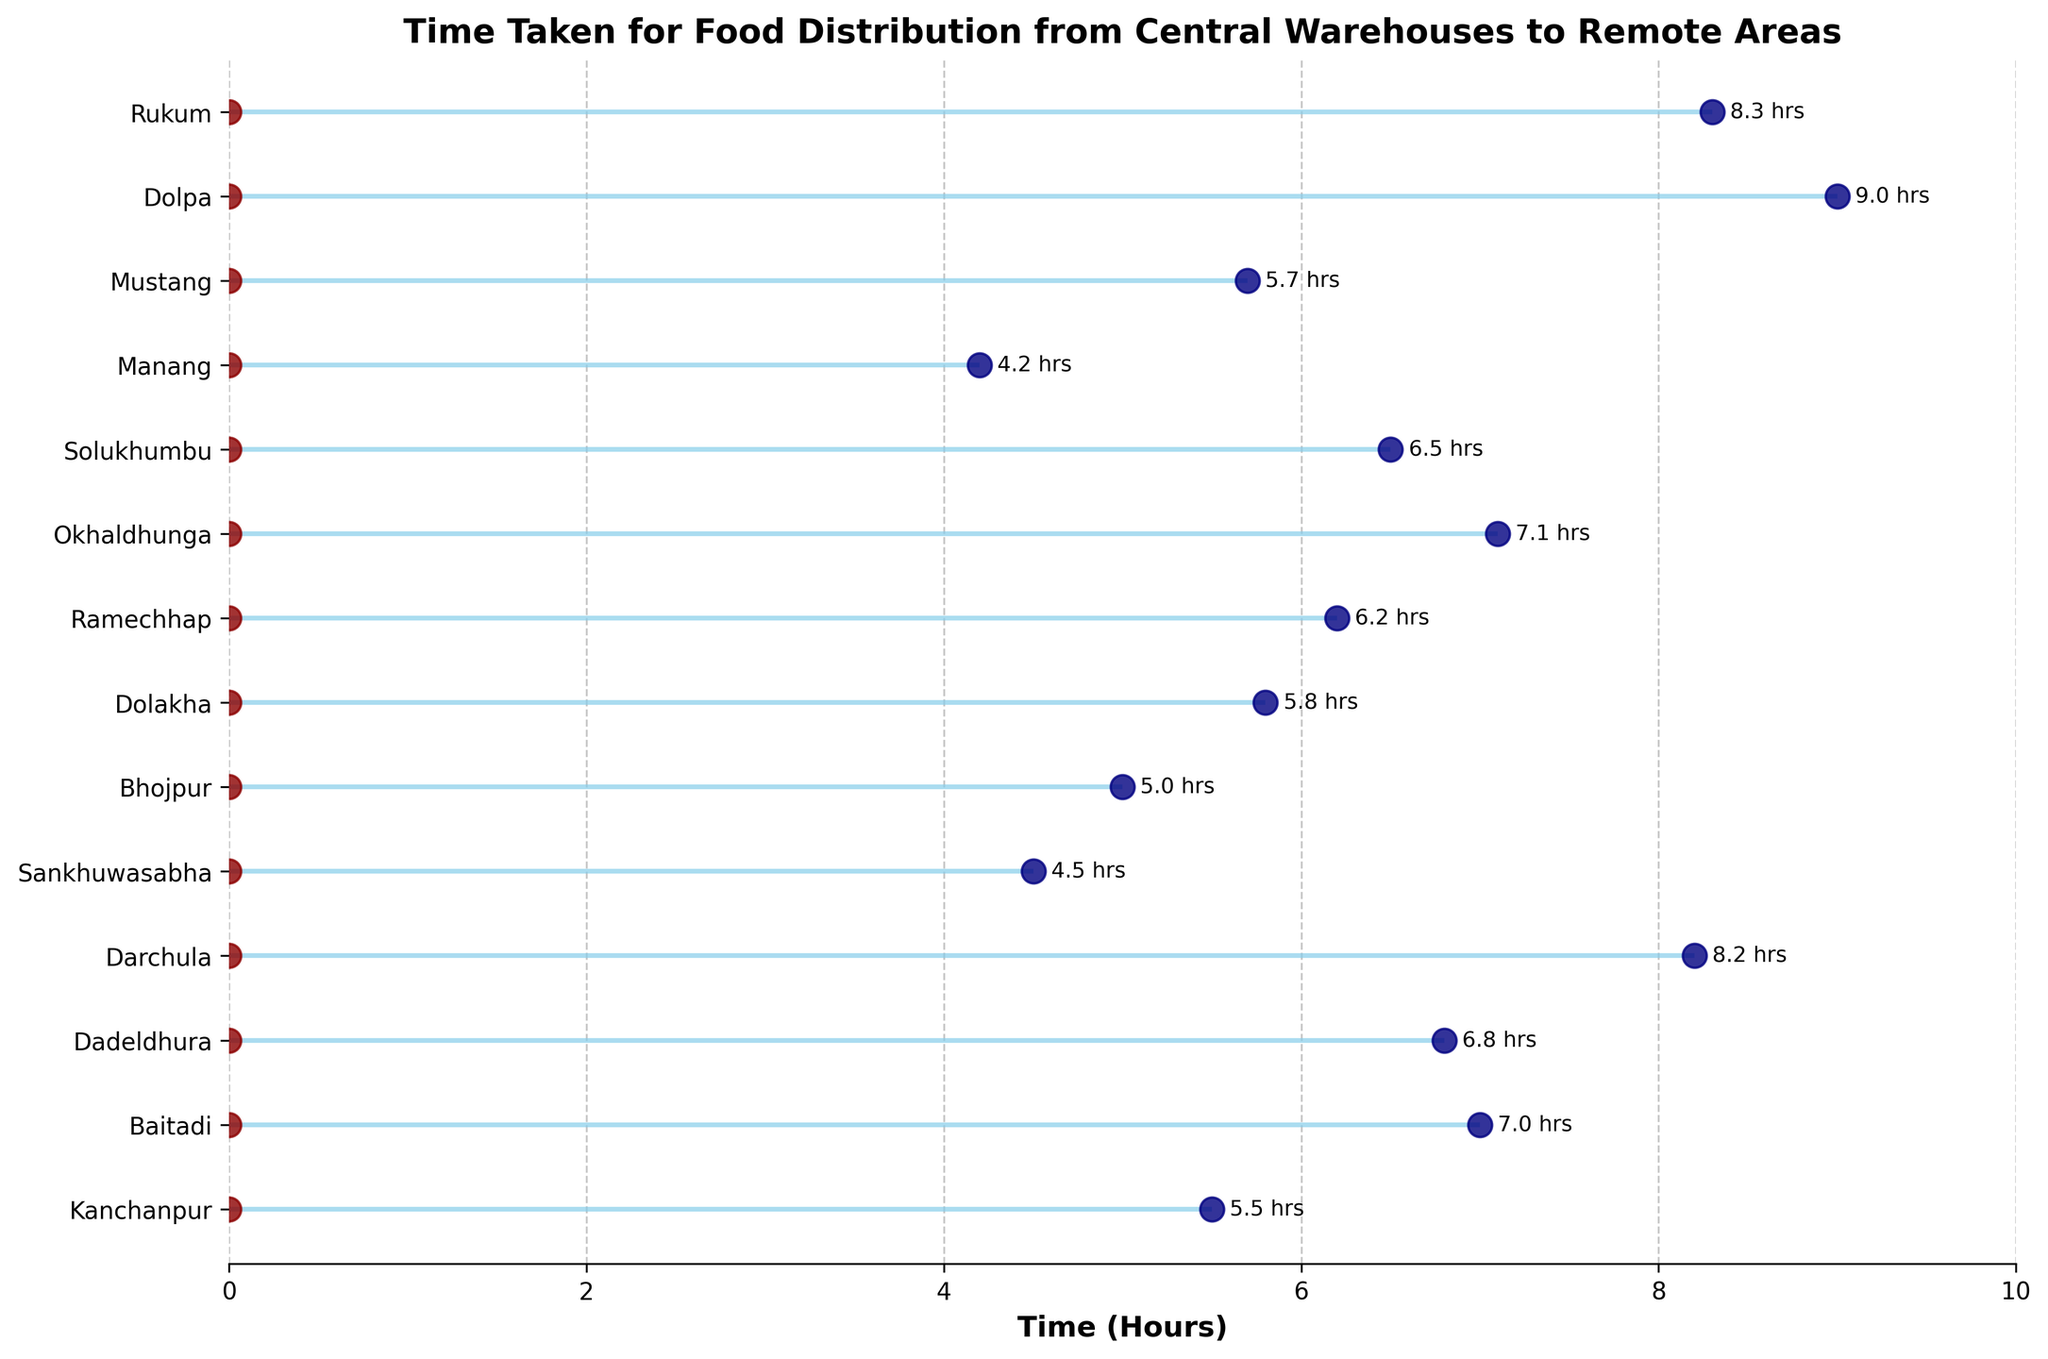What is the title of the plot? The title of the plot is located at the top and is written in bold. It summarizes the information presented in the plot.
Answer: Time Taken for Food Distribution from Central Warehouses to Remote Areas How many locations are represented in the plot? The number of tick marks along the y-axis corresponds to the number of locations.
Answer: 14 Which location took the longest time for food distribution? Identify the maximum point along the x-axis and match it to the corresponding location on the y-axis.
Answer: Dolpa What is the difference in distribution time between the longest and shortest locations? Identify the maximum time (Dolpa: 9.0 hours) and the minimum time (Manang: 4.2 hours) and calculate the difference (9.0 - 4.2).
Answer: 4.8 hours Which location took exactly 6.5 hours for food distribution? Identify the data point along the x-axis with a value of 6.5 hours and match it to the corresponding location on the y-axis.
Answer: Solukhumbu How many locations had a distribution time of 7 hours or longer? Count the number of data points along the x-axis that are at or beyond the 7-hour mark.
Answer: 4 Which two locations have times closest to 7.0 hours? Find the locations corresponding to the points near the 7-hour mark (Baitadi: 7.0, Okhaldhunga: 7.1), and determine their proximity.
Answer: Baitadi and Okhaldhunga What is the average time taken across all locations? Sum all the times and divide by the number of locations: (5.5 + 7.0 + 6.8 + 8.2 + 4.5 + 5.0 + 5.8 + 6.2 + 7.1 + 6.5 + 4.2 + 5.7 + 9.0 + 8.3) / 14 = 6.314 hours.
Answer: 6.3 hours Compare the distribution times between Sankhuwasabha and Mustang. Which one took longer? Identify the times for Sankhuwasabha (4.5 hours) and Mustang (5.7 hours) and compare them.
Answer: Mustang Which specific visual elements represent the starting and ending points in the plot? The starting points are represented by dark red dots at the origin (0 hours), and the ending points are represented by navy blue dots corresponding to the actual time on the x-axis.
Answer: Dark red dots (starting), navy blue dots (ending) 